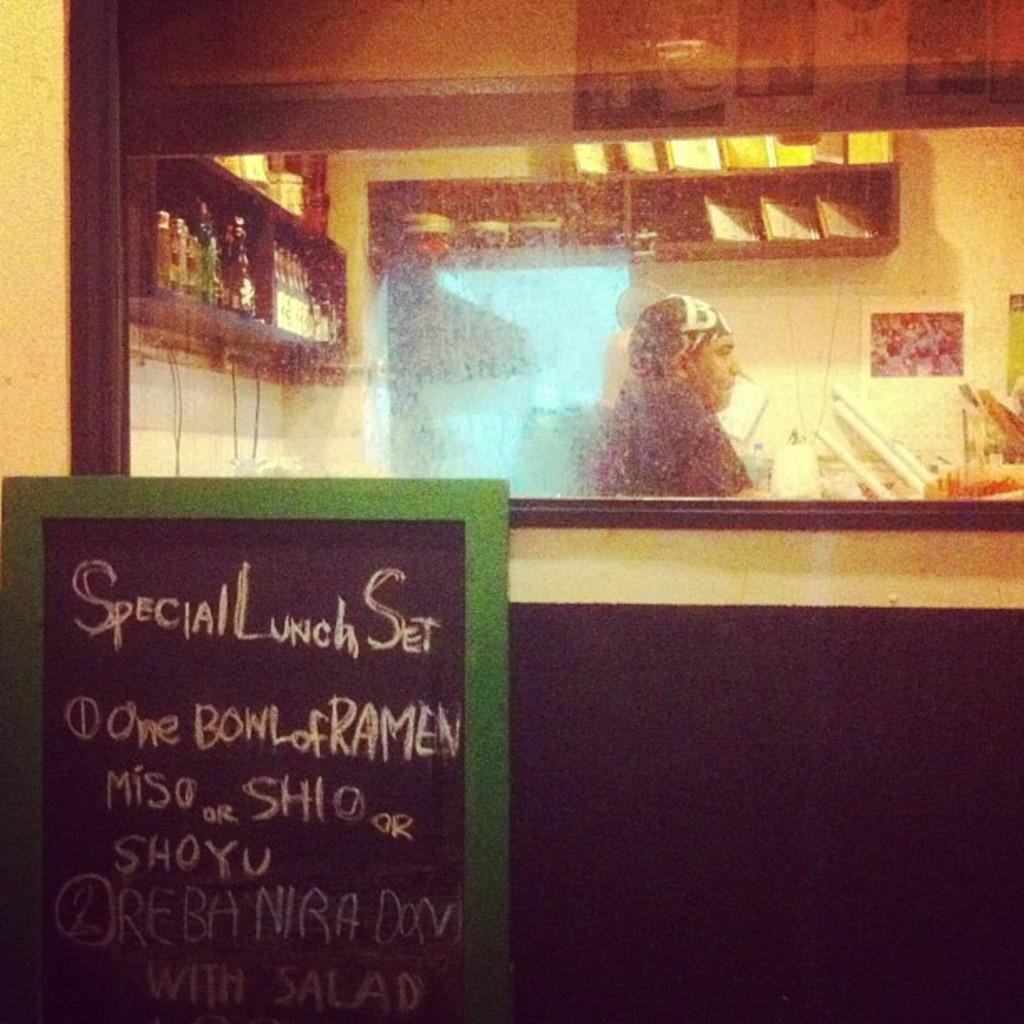Who or what is present in the image? There is a person in the image. What object can be seen in the image that might be used for displaying or storing items? There is a board and a rack in the image. What type of containers are visible in the image? There are bottles and a glass in the image. What can be seen in the background of the image? There is a wall in the image. What type of argument is the person having with the sea in the image? There is no sea present in the image, and therefore no argument can be observed. 